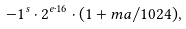<formula> <loc_0><loc_0><loc_500><loc_500>- 1 ^ { s } \cdot 2 ^ { e \cdot 1 6 } \cdot ( 1 + m a / 1 0 2 4 ) ,</formula> 